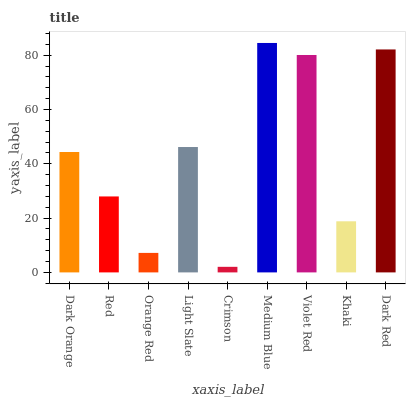Is Crimson the minimum?
Answer yes or no. Yes. Is Medium Blue the maximum?
Answer yes or no. Yes. Is Red the minimum?
Answer yes or no. No. Is Red the maximum?
Answer yes or no. No. Is Dark Orange greater than Red?
Answer yes or no. Yes. Is Red less than Dark Orange?
Answer yes or no. Yes. Is Red greater than Dark Orange?
Answer yes or no. No. Is Dark Orange less than Red?
Answer yes or no. No. Is Dark Orange the high median?
Answer yes or no. Yes. Is Dark Orange the low median?
Answer yes or no. Yes. Is Crimson the high median?
Answer yes or no. No. Is Crimson the low median?
Answer yes or no. No. 